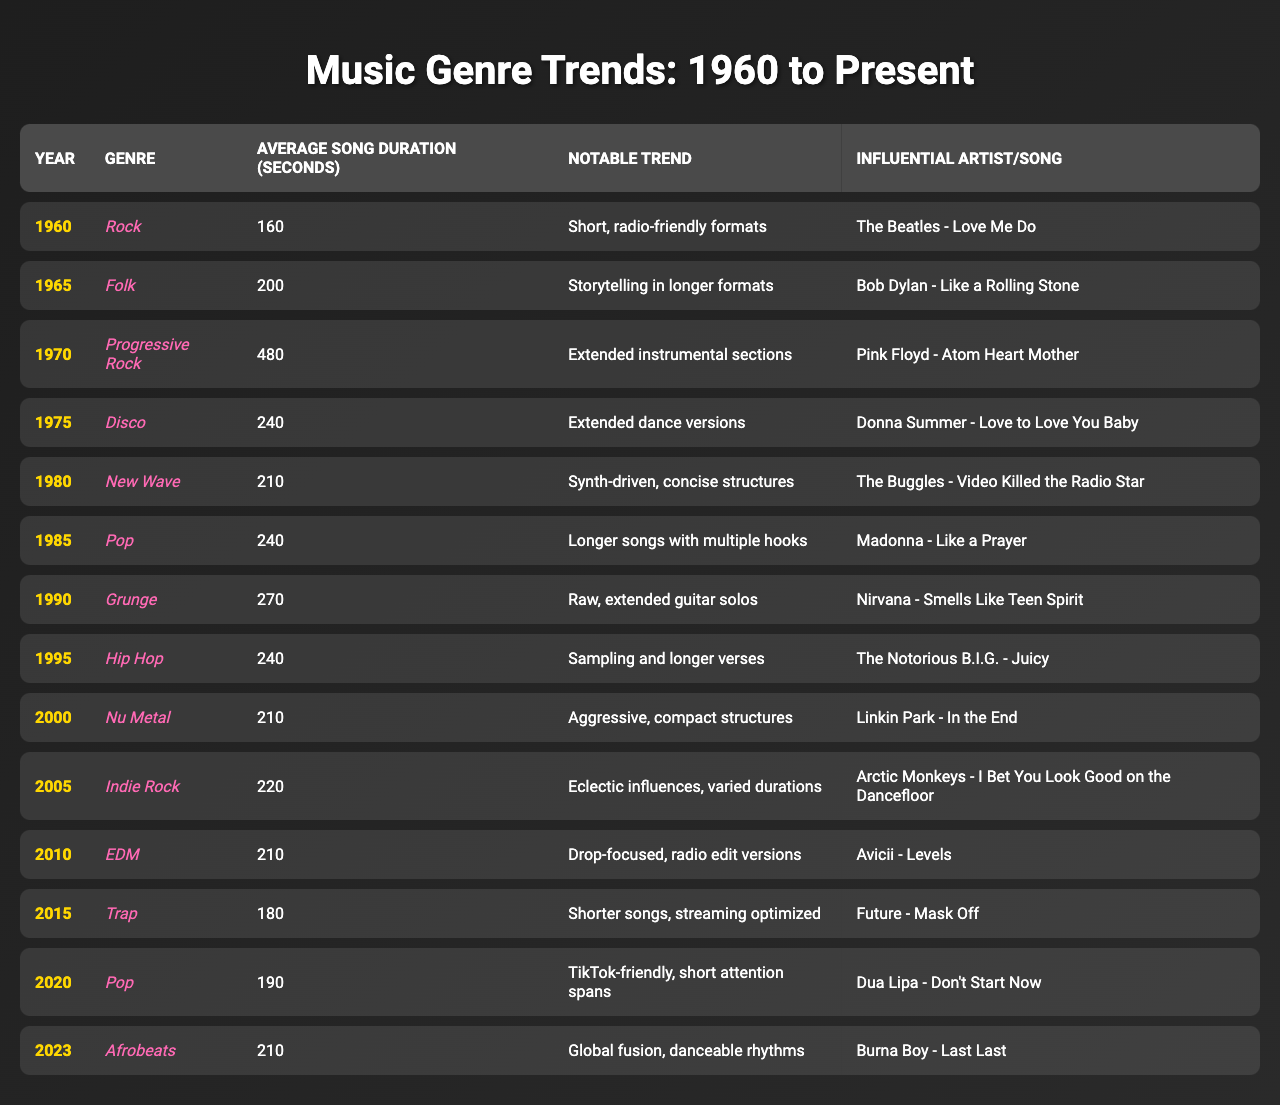What is the average song duration for the genre Disco in 1975? The table shows that the average song duration for Disco in 1975 is listed as 240 seconds.
Answer: 240 seconds Which genre had the longest average song duration and what was the year? According to the table, Progressive Rock was the genre with the longest average song duration at 480 seconds in 1970.
Answer: Progressive Rock, 1970 Has the average song duration increased or decreased from 2000 to 2020? Comparing the average song durations from the table, in 2000 it's 210 seconds, and in 2020 it is 190 seconds, indicating a decrease.
Answer: Decreased What notable trend is associated with Pop music in 2015? The table indicates that the notable trend associated with Pop music in 2015 is that songs became shorter to optimize for streaming.
Answer: Shorter songs, streaming optimized Which genre saw a significant shift towards storytelling and longer formats in the 1960s? Folk music is noted for its emphasis on storytelling and longer formats in the 1965 entry of the table.
Answer: Folk How many genres had an average song duration of 240 seconds? By examining the table, both Disco in 1975 and Hip Hop in 1995 had an average song duration of 240 seconds, indicating there are 2 genres.
Answer: 2 genres If we average the song durations of genres between 1970 and 2010, what is the result? The durations for Progressive Rock (480), Disco (240), New Wave (210), Pop (240), Grunge (270), Hip Hop (240), and Nu Metal (210) sum up to 1980 seconds. There are 7 genres, so dividing gives an average of 1980/7 ≈ 283 seconds.
Answer: 283 seconds Was there a trend in 2020 related to the attention spans of listeners? Yes, the table indicates that the trend in 2020 was toward songs being TikTok-friendly, reflecting shorter attention spans.
Answer: Yes What artist or song is linked to the notable trend of “extended dance versions” in 1975? The artist linked to that notable trend is Donna Summer with the song "Love to Love You Baby," as illustrated in the table.
Answer: Donna Summer - Love to Love You Baby Which genre experienced a notable trend towards drop-focused structures in 2010? The table specifies that the genre EDM saw a notable trend toward drop-focused structures in 2010.
Answer: EDM What is the notable trend associated with Trap music in 2015? The table states that the notable trend for Trap music in 2015 included shorter songs that are optimized for streaming.
Answer: Shorter songs, streaming optimized 